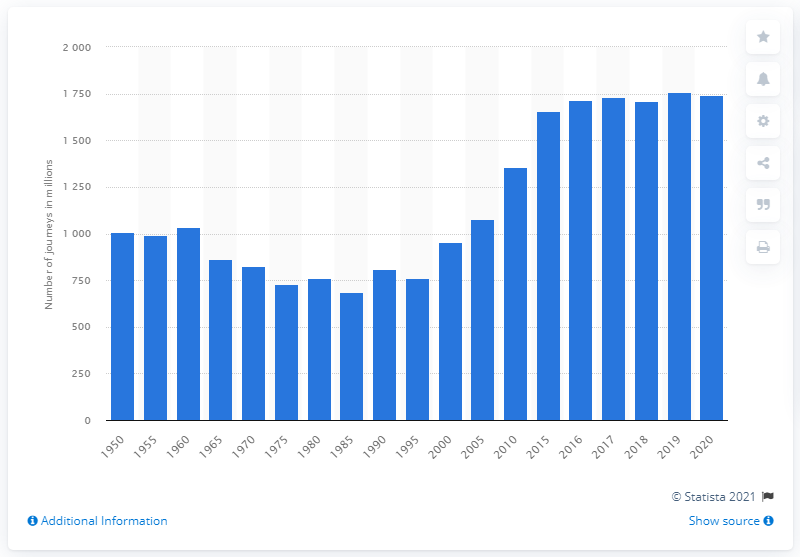Draw attention to some important aspects in this diagram. In the United Kingdom, the number of passenger journeys made on national rail services between 1950 and 2020 was 17,450. 